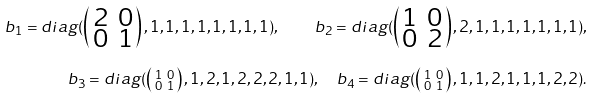<formula> <loc_0><loc_0><loc_500><loc_500>b _ { 1 } = d i a g ( \left ( \begin{smallmatrix} 2 & 0 \\ 0 & 1 \end{smallmatrix} \right ) , 1 , 1 , 1 , 1 , 1 , 1 , 1 , 1 ) , \quad b _ { 2 } = d i a g ( \left ( \begin{smallmatrix} 1 & 0 \\ 0 & 2 \end{smallmatrix} \right ) , 2 , 1 , 1 , 1 , 1 , 1 , 1 , 1 ) , \\ b _ { 3 } = d i a g ( \left ( \begin{smallmatrix} 1 & 0 \\ 0 & 1 \end{smallmatrix} \right ) , 1 , 2 , 1 , 2 , 2 , 2 , 1 , 1 ) , \quad b _ { 4 } = d i a g ( \left ( \begin{smallmatrix} 1 & 0 \\ 0 & 1 \end{smallmatrix} \right ) , 1 , 1 , 2 , 1 , 1 , 1 , 2 , 2 ) .</formula> 